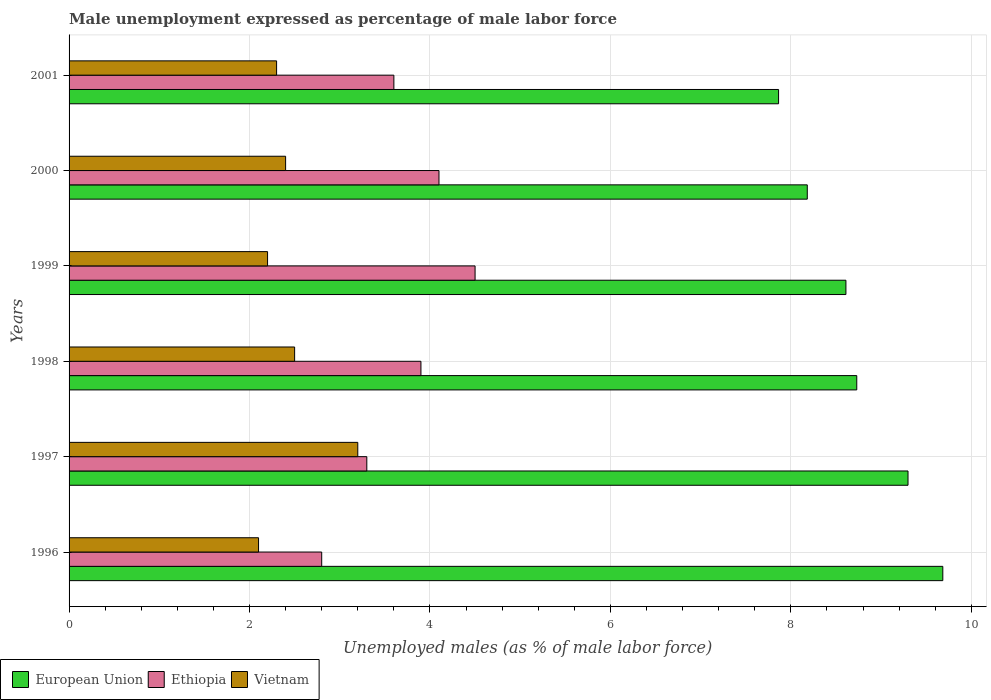How many different coloured bars are there?
Your answer should be very brief. 3. How many bars are there on the 1st tick from the bottom?
Offer a very short reply. 3. What is the unemployment in males in in Vietnam in 1999?
Make the answer very short. 2.2. Across all years, what is the maximum unemployment in males in in European Union?
Provide a short and direct response. 9.68. Across all years, what is the minimum unemployment in males in in Vietnam?
Provide a succinct answer. 2.1. In which year was the unemployment in males in in European Union minimum?
Your answer should be compact. 2001. What is the total unemployment in males in in European Union in the graph?
Your answer should be compact. 52.37. What is the difference between the unemployment in males in in Ethiopia in 1997 and that in 2000?
Make the answer very short. -0.8. What is the difference between the unemployment in males in in Ethiopia in 1996 and the unemployment in males in in Vietnam in 1999?
Offer a very short reply. 0.6. What is the average unemployment in males in in Vietnam per year?
Make the answer very short. 2.45. In the year 2000, what is the difference between the unemployment in males in in Vietnam and unemployment in males in in Ethiopia?
Keep it short and to the point. -1.7. What is the ratio of the unemployment in males in in European Union in 1996 to that in 1998?
Ensure brevity in your answer.  1.11. Is the unemployment in males in in Ethiopia in 1997 less than that in 2001?
Your answer should be very brief. Yes. Is the difference between the unemployment in males in in Vietnam in 1999 and 2000 greater than the difference between the unemployment in males in in Ethiopia in 1999 and 2000?
Provide a succinct answer. No. What is the difference between the highest and the second highest unemployment in males in in European Union?
Your response must be concise. 0.39. What is the difference between the highest and the lowest unemployment in males in in European Union?
Ensure brevity in your answer.  1.82. In how many years, is the unemployment in males in in European Union greater than the average unemployment in males in in European Union taken over all years?
Make the answer very short. 3. Is the sum of the unemployment in males in in Ethiopia in 1996 and 2001 greater than the maximum unemployment in males in in European Union across all years?
Ensure brevity in your answer.  No. What does the 3rd bar from the top in 2000 represents?
Provide a succinct answer. European Union. What does the 3rd bar from the bottom in 2000 represents?
Your response must be concise. Vietnam. Is it the case that in every year, the sum of the unemployment in males in in Ethiopia and unemployment in males in in European Union is greater than the unemployment in males in in Vietnam?
Provide a succinct answer. Yes. How many bars are there?
Provide a short and direct response. 18. How many years are there in the graph?
Give a very brief answer. 6. What is the difference between two consecutive major ticks on the X-axis?
Ensure brevity in your answer.  2. Does the graph contain grids?
Your response must be concise. Yes. What is the title of the graph?
Provide a short and direct response. Male unemployment expressed as percentage of male labor force. What is the label or title of the X-axis?
Ensure brevity in your answer.  Unemployed males (as % of male labor force). What is the Unemployed males (as % of male labor force) in European Union in 1996?
Keep it short and to the point. 9.68. What is the Unemployed males (as % of male labor force) in Ethiopia in 1996?
Make the answer very short. 2.8. What is the Unemployed males (as % of male labor force) in Vietnam in 1996?
Provide a short and direct response. 2.1. What is the Unemployed males (as % of male labor force) in European Union in 1997?
Keep it short and to the point. 9.3. What is the Unemployed males (as % of male labor force) of Ethiopia in 1997?
Offer a very short reply. 3.3. What is the Unemployed males (as % of male labor force) in Vietnam in 1997?
Give a very brief answer. 3.2. What is the Unemployed males (as % of male labor force) of European Union in 1998?
Make the answer very short. 8.73. What is the Unemployed males (as % of male labor force) in Ethiopia in 1998?
Your answer should be very brief. 3.9. What is the Unemployed males (as % of male labor force) in Vietnam in 1998?
Give a very brief answer. 2.5. What is the Unemployed males (as % of male labor force) of European Union in 1999?
Give a very brief answer. 8.61. What is the Unemployed males (as % of male labor force) of Ethiopia in 1999?
Make the answer very short. 4.5. What is the Unemployed males (as % of male labor force) of Vietnam in 1999?
Your response must be concise. 2.2. What is the Unemployed males (as % of male labor force) of European Union in 2000?
Ensure brevity in your answer.  8.18. What is the Unemployed males (as % of male labor force) in Ethiopia in 2000?
Keep it short and to the point. 4.1. What is the Unemployed males (as % of male labor force) in Vietnam in 2000?
Offer a terse response. 2.4. What is the Unemployed males (as % of male labor force) of European Union in 2001?
Your response must be concise. 7.86. What is the Unemployed males (as % of male labor force) of Ethiopia in 2001?
Your answer should be very brief. 3.6. What is the Unemployed males (as % of male labor force) in Vietnam in 2001?
Your answer should be very brief. 2.3. Across all years, what is the maximum Unemployed males (as % of male labor force) in European Union?
Your answer should be very brief. 9.68. Across all years, what is the maximum Unemployed males (as % of male labor force) of Vietnam?
Make the answer very short. 3.2. Across all years, what is the minimum Unemployed males (as % of male labor force) in European Union?
Give a very brief answer. 7.86. Across all years, what is the minimum Unemployed males (as % of male labor force) in Ethiopia?
Provide a succinct answer. 2.8. Across all years, what is the minimum Unemployed males (as % of male labor force) in Vietnam?
Keep it short and to the point. 2.1. What is the total Unemployed males (as % of male labor force) of European Union in the graph?
Provide a succinct answer. 52.37. What is the difference between the Unemployed males (as % of male labor force) in European Union in 1996 and that in 1997?
Your response must be concise. 0.39. What is the difference between the Unemployed males (as % of male labor force) of Ethiopia in 1996 and that in 1997?
Provide a succinct answer. -0.5. What is the difference between the Unemployed males (as % of male labor force) of Vietnam in 1996 and that in 1997?
Provide a short and direct response. -1.1. What is the difference between the Unemployed males (as % of male labor force) in European Union in 1996 and that in 1998?
Your answer should be compact. 0.95. What is the difference between the Unemployed males (as % of male labor force) of European Union in 1996 and that in 1999?
Offer a terse response. 1.07. What is the difference between the Unemployed males (as % of male labor force) in Ethiopia in 1996 and that in 1999?
Make the answer very short. -1.7. What is the difference between the Unemployed males (as % of male labor force) in European Union in 1996 and that in 2000?
Give a very brief answer. 1.5. What is the difference between the Unemployed males (as % of male labor force) in Ethiopia in 1996 and that in 2000?
Make the answer very short. -1.3. What is the difference between the Unemployed males (as % of male labor force) of Vietnam in 1996 and that in 2000?
Offer a very short reply. -0.3. What is the difference between the Unemployed males (as % of male labor force) of European Union in 1996 and that in 2001?
Your answer should be compact. 1.82. What is the difference between the Unemployed males (as % of male labor force) in Ethiopia in 1996 and that in 2001?
Make the answer very short. -0.8. What is the difference between the Unemployed males (as % of male labor force) of Vietnam in 1996 and that in 2001?
Keep it short and to the point. -0.2. What is the difference between the Unemployed males (as % of male labor force) in European Union in 1997 and that in 1998?
Provide a short and direct response. 0.57. What is the difference between the Unemployed males (as % of male labor force) in Ethiopia in 1997 and that in 1998?
Your response must be concise. -0.6. What is the difference between the Unemployed males (as % of male labor force) of European Union in 1997 and that in 1999?
Your response must be concise. 0.69. What is the difference between the Unemployed males (as % of male labor force) in European Union in 1997 and that in 2000?
Make the answer very short. 1.12. What is the difference between the Unemployed males (as % of male labor force) of Ethiopia in 1997 and that in 2000?
Give a very brief answer. -0.8. What is the difference between the Unemployed males (as % of male labor force) in European Union in 1997 and that in 2001?
Provide a short and direct response. 1.43. What is the difference between the Unemployed males (as % of male labor force) of Ethiopia in 1997 and that in 2001?
Ensure brevity in your answer.  -0.3. What is the difference between the Unemployed males (as % of male labor force) in Vietnam in 1997 and that in 2001?
Your answer should be compact. 0.9. What is the difference between the Unemployed males (as % of male labor force) in European Union in 1998 and that in 1999?
Make the answer very short. 0.12. What is the difference between the Unemployed males (as % of male labor force) of Ethiopia in 1998 and that in 1999?
Offer a very short reply. -0.6. What is the difference between the Unemployed males (as % of male labor force) of Vietnam in 1998 and that in 1999?
Give a very brief answer. 0.3. What is the difference between the Unemployed males (as % of male labor force) of European Union in 1998 and that in 2000?
Your answer should be very brief. 0.55. What is the difference between the Unemployed males (as % of male labor force) in Ethiopia in 1998 and that in 2000?
Your answer should be very brief. -0.2. What is the difference between the Unemployed males (as % of male labor force) of Vietnam in 1998 and that in 2000?
Your response must be concise. 0.1. What is the difference between the Unemployed males (as % of male labor force) in European Union in 1998 and that in 2001?
Give a very brief answer. 0.87. What is the difference between the Unemployed males (as % of male labor force) of European Union in 1999 and that in 2000?
Your response must be concise. 0.43. What is the difference between the Unemployed males (as % of male labor force) in Ethiopia in 1999 and that in 2000?
Your answer should be compact. 0.4. What is the difference between the Unemployed males (as % of male labor force) of European Union in 1999 and that in 2001?
Ensure brevity in your answer.  0.75. What is the difference between the Unemployed males (as % of male labor force) in European Union in 2000 and that in 2001?
Your response must be concise. 0.32. What is the difference between the Unemployed males (as % of male labor force) in European Union in 1996 and the Unemployed males (as % of male labor force) in Ethiopia in 1997?
Give a very brief answer. 6.38. What is the difference between the Unemployed males (as % of male labor force) of European Union in 1996 and the Unemployed males (as % of male labor force) of Vietnam in 1997?
Make the answer very short. 6.48. What is the difference between the Unemployed males (as % of male labor force) in European Union in 1996 and the Unemployed males (as % of male labor force) in Ethiopia in 1998?
Your answer should be compact. 5.78. What is the difference between the Unemployed males (as % of male labor force) of European Union in 1996 and the Unemployed males (as % of male labor force) of Vietnam in 1998?
Keep it short and to the point. 7.18. What is the difference between the Unemployed males (as % of male labor force) in Ethiopia in 1996 and the Unemployed males (as % of male labor force) in Vietnam in 1998?
Give a very brief answer. 0.3. What is the difference between the Unemployed males (as % of male labor force) of European Union in 1996 and the Unemployed males (as % of male labor force) of Ethiopia in 1999?
Provide a short and direct response. 5.18. What is the difference between the Unemployed males (as % of male labor force) of European Union in 1996 and the Unemployed males (as % of male labor force) of Vietnam in 1999?
Provide a short and direct response. 7.48. What is the difference between the Unemployed males (as % of male labor force) of European Union in 1996 and the Unemployed males (as % of male labor force) of Ethiopia in 2000?
Provide a short and direct response. 5.58. What is the difference between the Unemployed males (as % of male labor force) of European Union in 1996 and the Unemployed males (as % of male labor force) of Vietnam in 2000?
Provide a succinct answer. 7.28. What is the difference between the Unemployed males (as % of male labor force) in Ethiopia in 1996 and the Unemployed males (as % of male labor force) in Vietnam in 2000?
Provide a succinct answer. 0.4. What is the difference between the Unemployed males (as % of male labor force) in European Union in 1996 and the Unemployed males (as % of male labor force) in Ethiopia in 2001?
Provide a succinct answer. 6.08. What is the difference between the Unemployed males (as % of male labor force) of European Union in 1996 and the Unemployed males (as % of male labor force) of Vietnam in 2001?
Provide a short and direct response. 7.38. What is the difference between the Unemployed males (as % of male labor force) of Ethiopia in 1996 and the Unemployed males (as % of male labor force) of Vietnam in 2001?
Offer a very short reply. 0.5. What is the difference between the Unemployed males (as % of male labor force) in European Union in 1997 and the Unemployed males (as % of male labor force) in Ethiopia in 1998?
Provide a short and direct response. 5.4. What is the difference between the Unemployed males (as % of male labor force) of European Union in 1997 and the Unemployed males (as % of male labor force) of Vietnam in 1998?
Provide a succinct answer. 6.8. What is the difference between the Unemployed males (as % of male labor force) of Ethiopia in 1997 and the Unemployed males (as % of male labor force) of Vietnam in 1998?
Your answer should be very brief. 0.8. What is the difference between the Unemployed males (as % of male labor force) of European Union in 1997 and the Unemployed males (as % of male labor force) of Ethiopia in 1999?
Give a very brief answer. 4.8. What is the difference between the Unemployed males (as % of male labor force) in European Union in 1997 and the Unemployed males (as % of male labor force) in Vietnam in 1999?
Make the answer very short. 7.1. What is the difference between the Unemployed males (as % of male labor force) of Ethiopia in 1997 and the Unemployed males (as % of male labor force) of Vietnam in 1999?
Your answer should be very brief. 1.1. What is the difference between the Unemployed males (as % of male labor force) in European Union in 1997 and the Unemployed males (as % of male labor force) in Ethiopia in 2000?
Give a very brief answer. 5.2. What is the difference between the Unemployed males (as % of male labor force) of European Union in 1997 and the Unemployed males (as % of male labor force) of Vietnam in 2000?
Your response must be concise. 6.9. What is the difference between the Unemployed males (as % of male labor force) in European Union in 1997 and the Unemployed males (as % of male labor force) in Ethiopia in 2001?
Make the answer very short. 5.7. What is the difference between the Unemployed males (as % of male labor force) of European Union in 1997 and the Unemployed males (as % of male labor force) of Vietnam in 2001?
Ensure brevity in your answer.  7. What is the difference between the Unemployed males (as % of male labor force) in Ethiopia in 1997 and the Unemployed males (as % of male labor force) in Vietnam in 2001?
Offer a very short reply. 1. What is the difference between the Unemployed males (as % of male labor force) of European Union in 1998 and the Unemployed males (as % of male labor force) of Ethiopia in 1999?
Your answer should be very brief. 4.23. What is the difference between the Unemployed males (as % of male labor force) of European Union in 1998 and the Unemployed males (as % of male labor force) of Vietnam in 1999?
Make the answer very short. 6.53. What is the difference between the Unemployed males (as % of male labor force) in Ethiopia in 1998 and the Unemployed males (as % of male labor force) in Vietnam in 1999?
Offer a very short reply. 1.7. What is the difference between the Unemployed males (as % of male labor force) in European Union in 1998 and the Unemployed males (as % of male labor force) in Ethiopia in 2000?
Your response must be concise. 4.63. What is the difference between the Unemployed males (as % of male labor force) in European Union in 1998 and the Unemployed males (as % of male labor force) in Vietnam in 2000?
Provide a succinct answer. 6.33. What is the difference between the Unemployed males (as % of male labor force) of European Union in 1998 and the Unemployed males (as % of male labor force) of Ethiopia in 2001?
Your answer should be very brief. 5.13. What is the difference between the Unemployed males (as % of male labor force) of European Union in 1998 and the Unemployed males (as % of male labor force) of Vietnam in 2001?
Your response must be concise. 6.43. What is the difference between the Unemployed males (as % of male labor force) in European Union in 1999 and the Unemployed males (as % of male labor force) in Ethiopia in 2000?
Ensure brevity in your answer.  4.51. What is the difference between the Unemployed males (as % of male labor force) of European Union in 1999 and the Unemployed males (as % of male labor force) of Vietnam in 2000?
Your response must be concise. 6.21. What is the difference between the Unemployed males (as % of male labor force) in Ethiopia in 1999 and the Unemployed males (as % of male labor force) in Vietnam in 2000?
Give a very brief answer. 2.1. What is the difference between the Unemployed males (as % of male labor force) in European Union in 1999 and the Unemployed males (as % of male labor force) in Ethiopia in 2001?
Make the answer very short. 5.01. What is the difference between the Unemployed males (as % of male labor force) in European Union in 1999 and the Unemployed males (as % of male labor force) in Vietnam in 2001?
Ensure brevity in your answer.  6.31. What is the difference between the Unemployed males (as % of male labor force) of Ethiopia in 1999 and the Unemployed males (as % of male labor force) of Vietnam in 2001?
Your answer should be compact. 2.2. What is the difference between the Unemployed males (as % of male labor force) in European Union in 2000 and the Unemployed males (as % of male labor force) in Ethiopia in 2001?
Keep it short and to the point. 4.58. What is the difference between the Unemployed males (as % of male labor force) of European Union in 2000 and the Unemployed males (as % of male labor force) of Vietnam in 2001?
Give a very brief answer. 5.88. What is the difference between the Unemployed males (as % of male labor force) in Ethiopia in 2000 and the Unemployed males (as % of male labor force) in Vietnam in 2001?
Your answer should be compact. 1.8. What is the average Unemployed males (as % of male labor force) in European Union per year?
Your response must be concise. 8.73. What is the average Unemployed males (as % of male labor force) of Vietnam per year?
Provide a short and direct response. 2.45. In the year 1996, what is the difference between the Unemployed males (as % of male labor force) in European Union and Unemployed males (as % of male labor force) in Ethiopia?
Offer a very short reply. 6.88. In the year 1996, what is the difference between the Unemployed males (as % of male labor force) in European Union and Unemployed males (as % of male labor force) in Vietnam?
Make the answer very short. 7.58. In the year 1997, what is the difference between the Unemployed males (as % of male labor force) of European Union and Unemployed males (as % of male labor force) of Ethiopia?
Offer a very short reply. 6. In the year 1997, what is the difference between the Unemployed males (as % of male labor force) of European Union and Unemployed males (as % of male labor force) of Vietnam?
Offer a terse response. 6.1. In the year 1998, what is the difference between the Unemployed males (as % of male labor force) of European Union and Unemployed males (as % of male labor force) of Ethiopia?
Your answer should be compact. 4.83. In the year 1998, what is the difference between the Unemployed males (as % of male labor force) of European Union and Unemployed males (as % of male labor force) of Vietnam?
Ensure brevity in your answer.  6.23. In the year 1999, what is the difference between the Unemployed males (as % of male labor force) in European Union and Unemployed males (as % of male labor force) in Ethiopia?
Your answer should be compact. 4.11. In the year 1999, what is the difference between the Unemployed males (as % of male labor force) in European Union and Unemployed males (as % of male labor force) in Vietnam?
Provide a succinct answer. 6.41. In the year 1999, what is the difference between the Unemployed males (as % of male labor force) of Ethiopia and Unemployed males (as % of male labor force) of Vietnam?
Your answer should be very brief. 2.3. In the year 2000, what is the difference between the Unemployed males (as % of male labor force) of European Union and Unemployed males (as % of male labor force) of Ethiopia?
Your answer should be compact. 4.08. In the year 2000, what is the difference between the Unemployed males (as % of male labor force) in European Union and Unemployed males (as % of male labor force) in Vietnam?
Your answer should be very brief. 5.78. In the year 2000, what is the difference between the Unemployed males (as % of male labor force) of Ethiopia and Unemployed males (as % of male labor force) of Vietnam?
Provide a succinct answer. 1.7. In the year 2001, what is the difference between the Unemployed males (as % of male labor force) of European Union and Unemployed males (as % of male labor force) of Ethiopia?
Make the answer very short. 4.26. In the year 2001, what is the difference between the Unemployed males (as % of male labor force) of European Union and Unemployed males (as % of male labor force) of Vietnam?
Provide a succinct answer. 5.56. In the year 2001, what is the difference between the Unemployed males (as % of male labor force) of Ethiopia and Unemployed males (as % of male labor force) of Vietnam?
Offer a terse response. 1.3. What is the ratio of the Unemployed males (as % of male labor force) in European Union in 1996 to that in 1997?
Provide a short and direct response. 1.04. What is the ratio of the Unemployed males (as % of male labor force) of Ethiopia in 1996 to that in 1997?
Your answer should be compact. 0.85. What is the ratio of the Unemployed males (as % of male labor force) in Vietnam in 1996 to that in 1997?
Keep it short and to the point. 0.66. What is the ratio of the Unemployed males (as % of male labor force) of European Union in 1996 to that in 1998?
Make the answer very short. 1.11. What is the ratio of the Unemployed males (as % of male labor force) of Ethiopia in 1996 to that in 1998?
Your response must be concise. 0.72. What is the ratio of the Unemployed males (as % of male labor force) in Vietnam in 1996 to that in 1998?
Make the answer very short. 0.84. What is the ratio of the Unemployed males (as % of male labor force) of European Union in 1996 to that in 1999?
Give a very brief answer. 1.12. What is the ratio of the Unemployed males (as % of male labor force) in Ethiopia in 1996 to that in 1999?
Give a very brief answer. 0.62. What is the ratio of the Unemployed males (as % of male labor force) in Vietnam in 1996 to that in 1999?
Offer a terse response. 0.95. What is the ratio of the Unemployed males (as % of male labor force) in European Union in 1996 to that in 2000?
Offer a very short reply. 1.18. What is the ratio of the Unemployed males (as % of male labor force) of Ethiopia in 1996 to that in 2000?
Offer a terse response. 0.68. What is the ratio of the Unemployed males (as % of male labor force) in Vietnam in 1996 to that in 2000?
Your answer should be very brief. 0.88. What is the ratio of the Unemployed males (as % of male labor force) in European Union in 1996 to that in 2001?
Offer a terse response. 1.23. What is the ratio of the Unemployed males (as % of male labor force) in European Union in 1997 to that in 1998?
Ensure brevity in your answer.  1.07. What is the ratio of the Unemployed males (as % of male labor force) in Ethiopia in 1997 to that in 1998?
Offer a very short reply. 0.85. What is the ratio of the Unemployed males (as % of male labor force) of Vietnam in 1997 to that in 1998?
Your response must be concise. 1.28. What is the ratio of the Unemployed males (as % of male labor force) in European Union in 1997 to that in 1999?
Your answer should be very brief. 1.08. What is the ratio of the Unemployed males (as % of male labor force) in Ethiopia in 1997 to that in 1999?
Your response must be concise. 0.73. What is the ratio of the Unemployed males (as % of male labor force) of Vietnam in 1997 to that in 1999?
Provide a succinct answer. 1.45. What is the ratio of the Unemployed males (as % of male labor force) of European Union in 1997 to that in 2000?
Your answer should be compact. 1.14. What is the ratio of the Unemployed males (as % of male labor force) in Ethiopia in 1997 to that in 2000?
Ensure brevity in your answer.  0.8. What is the ratio of the Unemployed males (as % of male labor force) in European Union in 1997 to that in 2001?
Your response must be concise. 1.18. What is the ratio of the Unemployed males (as % of male labor force) in Ethiopia in 1997 to that in 2001?
Make the answer very short. 0.92. What is the ratio of the Unemployed males (as % of male labor force) of Vietnam in 1997 to that in 2001?
Provide a succinct answer. 1.39. What is the ratio of the Unemployed males (as % of male labor force) in Ethiopia in 1998 to that in 1999?
Provide a short and direct response. 0.87. What is the ratio of the Unemployed males (as % of male labor force) of Vietnam in 1998 to that in 1999?
Offer a terse response. 1.14. What is the ratio of the Unemployed males (as % of male labor force) in European Union in 1998 to that in 2000?
Ensure brevity in your answer.  1.07. What is the ratio of the Unemployed males (as % of male labor force) of Ethiopia in 1998 to that in 2000?
Provide a succinct answer. 0.95. What is the ratio of the Unemployed males (as % of male labor force) of Vietnam in 1998 to that in 2000?
Your response must be concise. 1.04. What is the ratio of the Unemployed males (as % of male labor force) of European Union in 1998 to that in 2001?
Your response must be concise. 1.11. What is the ratio of the Unemployed males (as % of male labor force) in Vietnam in 1998 to that in 2001?
Provide a short and direct response. 1.09. What is the ratio of the Unemployed males (as % of male labor force) of European Union in 1999 to that in 2000?
Offer a terse response. 1.05. What is the ratio of the Unemployed males (as % of male labor force) in Ethiopia in 1999 to that in 2000?
Offer a terse response. 1.1. What is the ratio of the Unemployed males (as % of male labor force) of European Union in 1999 to that in 2001?
Give a very brief answer. 1.09. What is the ratio of the Unemployed males (as % of male labor force) of Ethiopia in 1999 to that in 2001?
Give a very brief answer. 1.25. What is the ratio of the Unemployed males (as % of male labor force) in Vietnam in 1999 to that in 2001?
Keep it short and to the point. 0.96. What is the ratio of the Unemployed males (as % of male labor force) in European Union in 2000 to that in 2001?
Keep it short and to the point. 1.04. What is the ratio of the Unemployed males (as % of male labor force) in Ethiopia in 2000 to that in 2001?
Offer a very short reply. 1.14. What is the ratio of the Unemployed males (as % of male labor force) in Vietnam in 2000 to that in 2001?
Offer a very short reply. 1.04. What is the difference between the highest and the second highest Unemployed males (as % of male labor force) in European Union?
Your answer should be compact. 0.39. What is the difference between the highest and the second highest Unemployed males (as % of male labor force) in Ethiopia?
Give a very brief answer. 0.4. What is the difference between the highest and the lowest Unemployed males (as % of male labor force) in European Union?
Your answer should be compact. 1.82. What is the difference between the highest and the lowest Unemployed males (as % of male labor force) in Ethiopia?
Give a very brief answer. 1.7. 